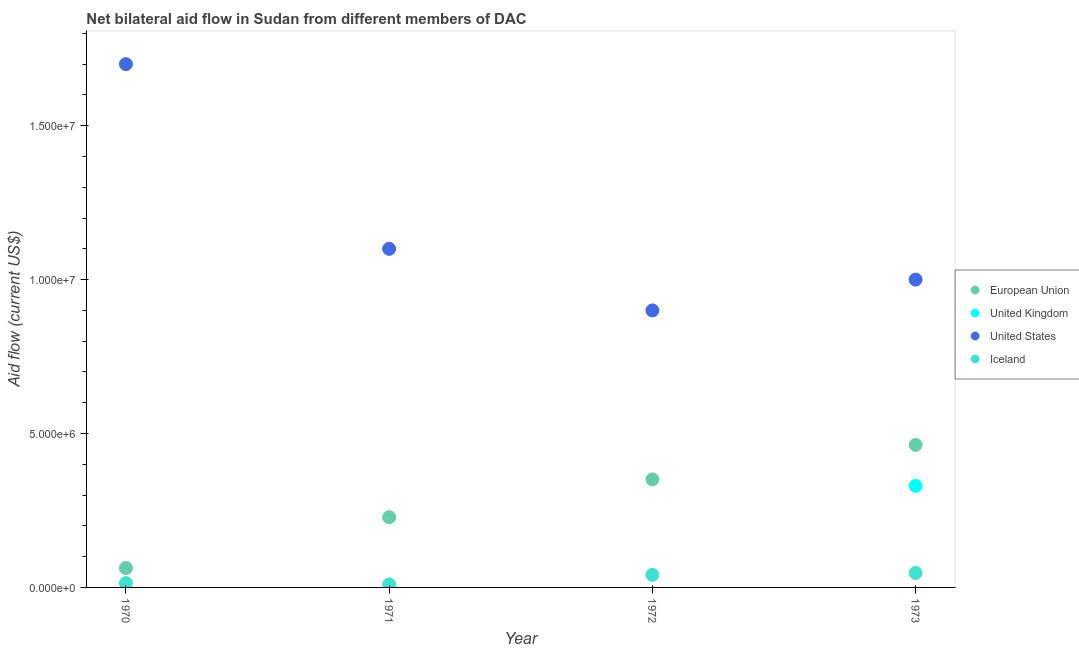How many different coloured dotlines are there?
Offer a very short reply. 4. Is the number of dotlines equal to the number of legend labels?
Ensure brevity in your answer.  No. What is the amount of aid given by iceland in 1972?
Offer a very short reply. 4.10e+05. Across all years, what is the maximum amount of aid given by iceland?
Provide a succinct answer. 4.70e+05. Across all years, what is the minimum amount of aid given by iceland?
Give a very brief answer. 1.00e+05. What is the total amount of aid given by uk in the graph?
Your response must be concise. 3.30e+06. What is the difference between the amount of aid given by eu in 1971 and that in 1973?
Give a very brief answer. -2.35e+06. What is the difference between the amount of aid given by eu in 1972 and the amount of aid given by us in 1973?
Ensure brevity in your answer.  -6.49e+06. What is the average amount of aid given by iceland per year?
Your answer should be very brief. 2.80e+05. In the year 1972, what is the difference between the amount of aid given by us and amount of aid given by iceland?
Your response must be concise. 8.59e+06. What is the ratio of the amount of aid given by eu in 1970 to that in 1973?
Make the answer very short. 0.14. Is the amount of aid given by iceland in 1970 less than that in 1972?
Make the answer very short. Yes. Is the difference between the amount of aid given by iceland in 1970 and 1971 greater than the difference between the amount of aid given by eu in 1970 and 1971?
Make the answer very short. Yes. What is the difference between the highest and the second highest amount of aid given by eu?
Keep it short and to the point. 1.12e+06. What is the difference between the highest and the lowest amount of aid given by us?
Your answer should be compact. 8.00e+06. In how many years, is the amount of aid given by eu greater than the average amount of aid given by eu taken over all years?
Your response must be concise. 2. Is it the case that in every year, the sum of the amount of aid given by us and amount of aid given by iceland is greater than the sum of amount of aid given by eu and amount of aid given by uk?
Provide a short and direct response. Yes. Is it the case that in every year, the sum of the amount of aid given by eu and amount of aid given by uk is greater than the amount of aid given by us?
Your response must be concise. No. Does the amount of aid given by eu monotonically increase over the years?
Your answer should be very brief. Yes. Is the amount of aid given by us strictly greater than the amount of aid given by eu over the years?
Your response must be concise. Yes. Is the amount of aid given by uk strictly less than the amount of aid given by eu over the years?
Make the answer very short. Yes. How many dotlines are there?
Your answer should be very brief. 4. What is the difference between two consecutive major ticks on the Y-axis?
Offer a terse response. 5.00e+06. What is the title of the graph?
Your answer should be very brief. Net bilateral aid flow in Sudan from different members of DAC. What is the label or title of the X-axis?
Provide a succinct answer. Year. What is the label or title of the Y-axis?
Make the answer very short. Aid flow (current US$). What is the Aid flow (current US$) in European Union in 1970?
Keep it short and to the point. 6.30e+05. What is the Aid flow (current US$) in United States in 1970?
Your answer should be compact. 1.70e+07. What is the Aid flow (current US$) in Iceland in 1970?
Keep it short and to the point. 1.40e+05. What is the Aid flow (current US$) in European Union in 1971?
Your response must be concise. 2.28e+06. What is the Aid flow (current US$) of United States in 1971?
Your answer should be very brief. 1.10e+07. What is the Aid flow (current US$) in European Union in 1972?
Offer a terse response. 3.51e+06. What is the Aid flow (current US$) in United Kingdom in 1972?
Offer a very short reply. 0. What is the Aid flow (current US$) in United States in 1972?
Ensure brevity in your answer.  9.00e+06. What is the Aid flow (current US$) in Iceland in 1972?
Make the answer very short. 4.10e+05. What is the Aid flow (current US$) in European Union in 1973?
Your response must be concise. 4.63e+06. What is the Aid flow (current US$) in United Kingdom in 1973?
Provide a succinct answer. 3.30e+06. What is the Aid flow (current US$) in Iceland in 1973?
Provide a short and direct response. 4.70e+05. Across all years, what is the maximum Aid flow (current US$) of European Union?
Make the answer very short. 4.63e+06. Across all years, what is the maximum Aid flow (current US$) of United Kingdom?
Keep it short and to the point. 3.30e+06. Across all years, what is the maximum Aid flow (current US$) in United States?
Give a very brief answer. 1.70e+07. Across all years, what is the minimum Aid flow (current US$) of European Union?
Your response must be concise. 6.30e+05. Across all years, what is the minimum Aid flow (current US$) of United States?
Offer a very short reply. 9.00e+06. What is the total Aid flow (current US$) of European Union in the graph?
Keep it short and to the point. 1.10e+07. What is the total Aid flow (current US$) in United Kingdom in the graph?
Make the answer very short. 3.30e+06. What is the total Aid flow (current US$) in United States in the graph?
Keep it short and to the point. 4.70e+07. What is the total Aid flow (current US$) in Iceland in the graph?
Offer a terse response. 1.12e+06. What is the difference between the Aid flow (current US$) of European Union in 1970 and that in 1971?
Give a very brief answer. -1.65e+06. What is the difference between the Aid flow (current US$) in Iceland in 1970 and that in 1971?
Provide a succinct answer. 4.00e+04. What is the difference between the Aid flow (current US$) in European Union in 1970 and that in 1972?
Ensure brevity in your answer.  -2.88e+06. What is the difference between the Aid flow (current US$) of United States in 1970 and that in 1972?
Keep it short and to the point. 8.00e+06. What is the difference between the Aid flow (current US$) in European Union in 1970 and that in 1973?
Your answer should be compact. -4.00e+06. What is the difference between the Aid flow (current US$) of Iceland in 1970 and that in 1973?
Give a very brief answer. -3.30e+05. What is the difference between the Aid flow (current US$) in European Union in 1971 and that in 1972?
Your answer should be very brief. -1.23e+06. What is the difference between the Aid flow (current US$) in United States in 1971 and that in 1972?
Your answer should be very brief. 2.00e+06. What is the difference between the Aid flow (current US$) of Iceland in 1971 and that in 1972?
Give a very brief answer. -3.10e+05. What is the difference between the Aid flow (current US$) of European Union in 1971 and that in 1973?
Offer a terse response. -2.35e+06. What is the difference between the Aid flow (current US$) in Iceland in 1971 and that in 1973?
Keep it short and to the point. -3.70e+05. What is the difference between the Aid flow (current US$) of European Union in 1972 and that in 1973?
Give a very brief answer. -1.12e+06. What is the difference between the Aid flow (current US$) of United States in 1972 and that in 1973?
Your answer should be compact. -1.00e+06. What is the difference between the Aid flow (current US$) in Iceland in 1972 and that in 1973?
Your answer should be very brief. -6.00e+04. What is the difference between the Aid flow (current US$) of European Union in 1970 and the Aid flow (current US$) of United States in 1971?
Provide a short and direct response. -1.04e+07. What is the difference between the Aid flow (current US$) of European Union in 1970 and the Aid flow (current US$) of Iceland in 1971?
Your response must be concise. 5.30e+05. What is the difference between the Aid flow (current US$) of United States in 1970 and the Aid flow (current US$) of Iceland in 1971?
Keep it short and to the point. 1.69e+07. What is the difference between the Aid flow (current US$) of European Union in 1970 and the Aid flow (current US$) of United States in 1972?
Offer a terse response. -8.37e+06. What is the difference between the Aid flow (current US$) of United States in 1970 and the Aid flow (current US$) of Iceland in 1972?
Keep it short and to the point. 1.66e+07. What is the difference between the Aid flow (current US$) in European Union in 1970 and the Aid flow (current US$) in United Kingdom in 1973?
Provide a short and direct response. -2.67e+06. What is the difference between the Aid flow (current US$) of European Union in 1970 and the Aid flow (current US$) of United States in 1973?
Provide a short and direct response. -9.37e+06. What is the difference between the Aid flow (current US$) in European Union in 1970 and the Aid flow (current US$) in Iceland in 1973?
Keep it short and to the point. 1.60e+05. What is the difference between the Aid flow (current US$) in United States in 1970 and the Aid flow (current US$) in Iceland in 1973?
Provide a succinct answer. 1.65e+07. What is the difference between the Aid flow (current US$) of European Union in 1971 and the Aid flow (current US$) of United States in 1972?
Make the answer very short. -6.72e+06. What is the difference between the Aid flow (current US$) of European Union in 1971 and the Aid flow (current US$) of Iceland in 1972?
Provide a succinct answer. 1.87e+06. What is the difference between the Aid flow (current US$) in United States in 1971 and the Aid flow (current US$) in Iceland in 1972?
Make the answer very short. 1.06e+07. What is the difference between the Aid flow (current US$) of European Union in 1971 and the Aid flow (current US$) of United Kingdom in 1973?
Keep it short and to the point. -1.02e+06. What is the difference between the Aid flow (current US$) in European Union in 1971 and the Aid flow (current US$) in United States in 1973?
Your answer should be very brief. -7.72e+06. What is the difference between the Aid flow (current US$) of European Union in 1971 and the Aid flow (current US$) of Iceland in 1973?
Provide a short and direct response. 1.81e+06. What is the difference between the Aid flow (current US$) of United States in 1971 and the Aid flow (current US$) of Iceland in 1973?
Give a very brief answer. 1.05e+07. What is the difference between the Aid flow (current US$) of European Union in 1972 and the Aid flow (current US$) of United States in 1973?
Your response must be concise. -6.49e+06. What is the difference between the Aid flow (current US$) of European Union in 1972 and the Aid flow (current US$) of Iceland in 1973?
Keep it short and to the point. 3.04e+06. What is the difference between the Aid flow (current US$) in United States in 1972 and the Aid flow (current US$) in Iceland in 1973?
Provide a short and direct response. 8.53e+06. What is the average Aid flow (current US$) of European Union per year?
Give a very brief answer. 2.76e+06. What is the average Aid flow (current US$) of United Kingdom per year?
Your answer should be compact. 8.25e+05. What is the average Aid flow (current US$) in United States per year?
Your answer should be very brief. 1.18e+07. What is the average Aid flow (current US$) of Iceland per year?
Provide a short and direct response. 2.80e+05. In the year 1970, what is the difference between the Aid flow (current US$) of European Union and Aid flow (current US$) of United States?
Offer a very short reply. -1.64e+07. In the year 1970, what is the difference between the Aid flow (current US$) of United States and Aid flow (current US$) of Iceland?
Offer a terse response. 1.69e+07. In the year 1971, what is the difference between the Aid flow (current US$) of European Union and Aid flow (current US$) of United States?
Ensure brevity in your answer.  -8.72e+06. In the year 1971, what is the difference between the Aid flow (current US$) in European Union and Aid flow (current US$) in Iceland?
Offer a very short reply. 2.18e+06. In the year 1971, what is the difference between the Aid flow (current US$) of United States and Aid flow (current US$) of Iceland?
Make the answer very short. 1.09e+07. In the year 1972, what is the difference between the Aid flow (current US$) in European Union and Aid flow (current US$) in United States?
Your answer should be compact. -5.49e+06. In the year 1972, what is the difference between the Aid flow (current US$) in European Union and Aid flow (current US$) in Iceland?
Ensure brevity in your answer.  3.10e+06. In the year 1972, what is the difference between the Aid flow (current US$) of United States and Aid flow (current US$) of Iceland?
Keep it short and to the point. 8.59e+06. In the year 1973, what is the difference between the Aid flow (current US$) in European Union and Aid flow (current US$) in United Kingdom?
Your answer should be very brief. 1.33e+06. In the year 1973, what is the difference between the Aid flow (current US$) of European Union and Aid flow (current US$) of United States?
Your answer should be very brief. -5.37e+06. In the year 1973, what is the difference between the Aid flow (current US$) of European Union and Aid flow (current US$) of Iceland?
Offer a terse response. 4.16e+06. In the year 1973, what is the difference between the Aid flow (current US$) in United Kingdom and Aid flow (current US$) in United States?
Keep it short and to the point. -6.70e+06. In the year 1973, what is the difference between the Aid flow (current US$) in United Kingdom and Aid flow (current US$) in Iceland?
Keep it short and to the point. 2.83e+06. In the year 1973, what is the difference between the Aid flow (current US$) in United States and Aid flow (current US$) in Iceland?
Make the answer very short. 9.53e+06. What is the ratio of the Aid flow (current US$) in European Union in 1970 to that in 1971?
Ensure brevity in your answer.  0.28. What is the ratio of the Aid flow (current US$) in United States in 1970 to that in 1971?
Your response must be concise. 1.55. What is the ratio of the Aid flow (current US$) of European Union in 1970 to that in 1972?
Make the answer very short. 0.18. What is the ratio of the Aid flow (current US$) in United States in 1970 to that in 1972?
Offer a terse response. 1.89. What is the ratio of the Aid flow (current US$) of Iceland in 1970 to that in 1972?
Make the answer very short. 0.34. What is the ratio of the Aid flow (current US$) of European Union in 1970 to that in 1973?
Keep it short and to the point. 0.14. What is the ratio of the Aid flow (current US$) in United States in 1970 to that in 1973?
Make the answer very short. 1.7. What is the ratio of the Aid flow (current US$) in Iceland in 1970 to that in 1973?
Offer a terse response. 0.3. What is the ratio of the Aid flow (current US$) of European Union in 1971 to that in 1972?
Keep it short and to the point. 0.65. What is the ratio of the Aid flow (current US$) in United States in 1971 to that in 1972?
Make the answer very short. 1.22. What is the ratio of the Aid flow (current US$) in Iceland in 1971 to that in 1972?
Make the answer very short. 0.24. What is the ratio of the Aid flow (current US$) in European Union in 1971 to that in 1973?
Your response must be concise. 0.49. What is the ratio of the Aid flow (current US$) of United States in 1971 to that in 1973?
Provide a short and direct response. 1.1. What is the ratio of the Aid flow (current US$) of Iceland in 1971 to that in 1973?
Offer a terse response. 0.21. What is the ratio of the Aid flow (current US$) of European Union in 1972 to that in 1973?
Ensure brevity in your answer.  0.76. What is the ratio of the Aid flow (current US$) of Iceland in 1972 to that in 1973?
Offer a terse response. 0.87. What is the difference between the highest and the second highest Aid flow (current US$) in European Union?
Ensure brevity in your answer.  1.12e+06. What is the difference between the highest and the second highest Aid flow (current US$) in United States?
Provide a succinct answer. 6.00e+06. What is the difference between the highest and the second highest Aid flow (current US$) of Iceland?
Offer a terse response. 6.00e+04. What is the difference between the highest and the lowest Aid flow (current US$) of European Union?
Provide a succinct answer. 4.00e+06. What is the difference between the highest and the lowest Aid flow (current US$) in United Kingdom?
Provide a succinct answer. 3.30e+06. What is the difference between the highest and the lowest Aid flow (current US$) in Iceland?
Provide a succinct answer. 3.70e+05. 